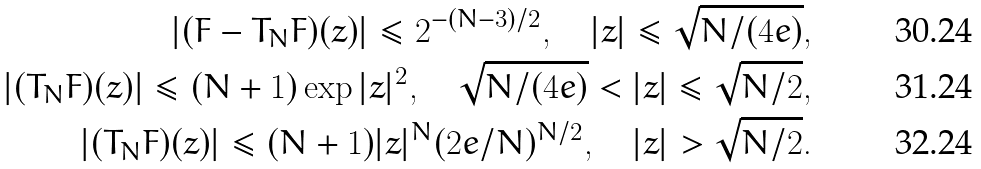Convert formula to latex. <formula><loc_0><loc_0><loc_500><loc_500>| ( F - T _ { N } F ) ( z ) | \leq 2 ^ { - ( N - 3 ) / 2 } , \quad | z | \leq \sqrt { N / ( 4 e ) } , \\ | ( T _ { N } F ) ( z ) | \leq ( N + 1 ) \exp | z | ^ { 2 } , \quad \sqrt { N / ( 4 e ) } < | z | \leq \sqrt { N / 2 } , \\ | ( T _ { N } F ) ( z ) | \leq ( N + 1 ) | z | ^ { N } ( 2 e / N ) ^ { N / 2 } , \quad | z | > \sqrt { N / 2 } .</formula> 